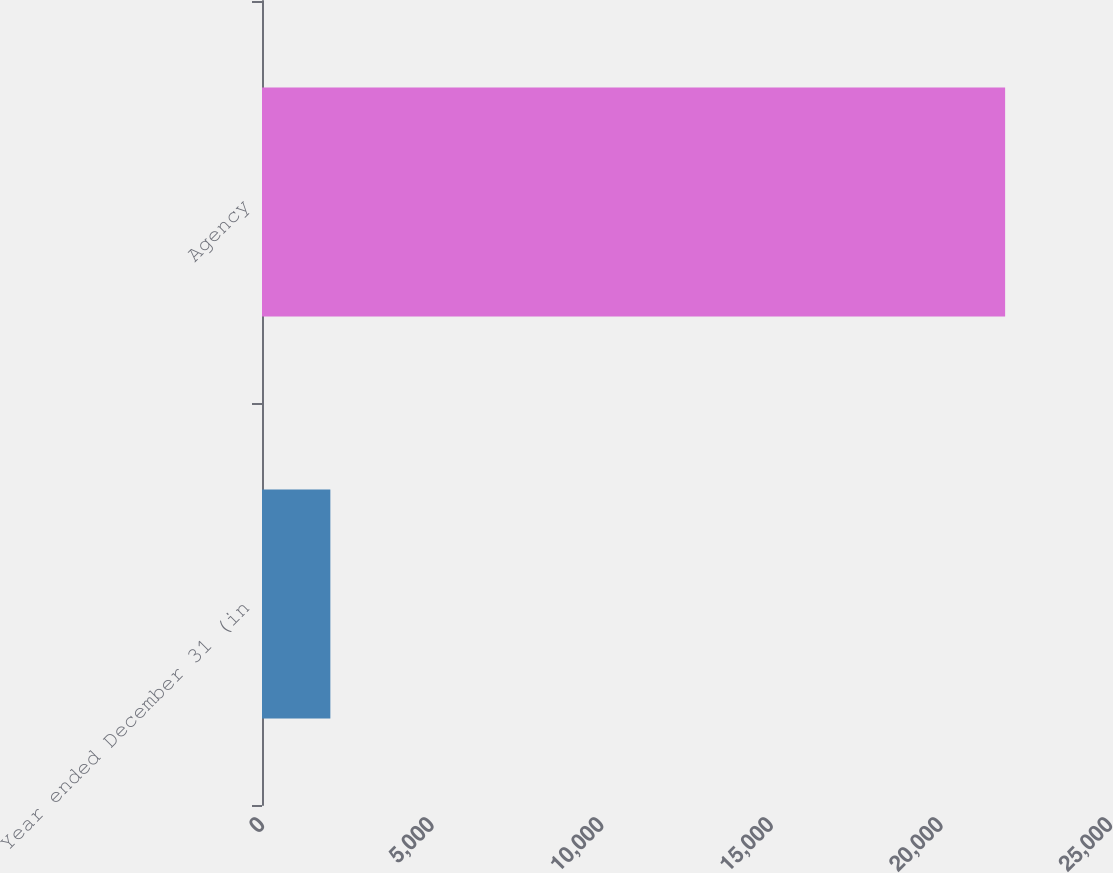Convert chart. <chart><loc_0><loc_0><loc_500><loc_500><bar_chart><fcel>Year ended December 31 (in<fcel>Agency<nl><fcel>2015<fcel>21908<nl></chart> 